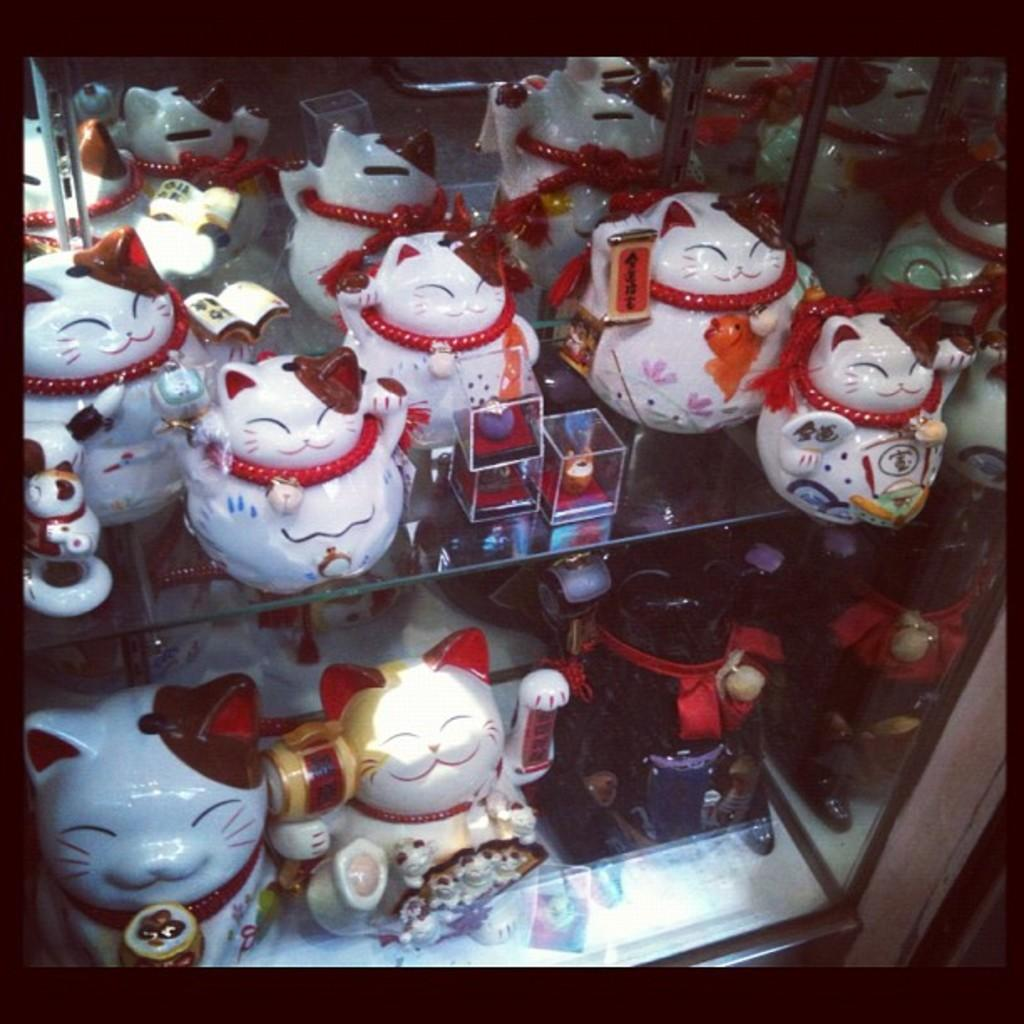What type of storage or display system is shown in the image? There are glass racks in the image. What can be seen on the glass racks? There are red and white toys on the glass racks. What type of beast is hiding behind the glass racks in the image? There is no beast present in the image; it only shows glass racks with red and white toys. 